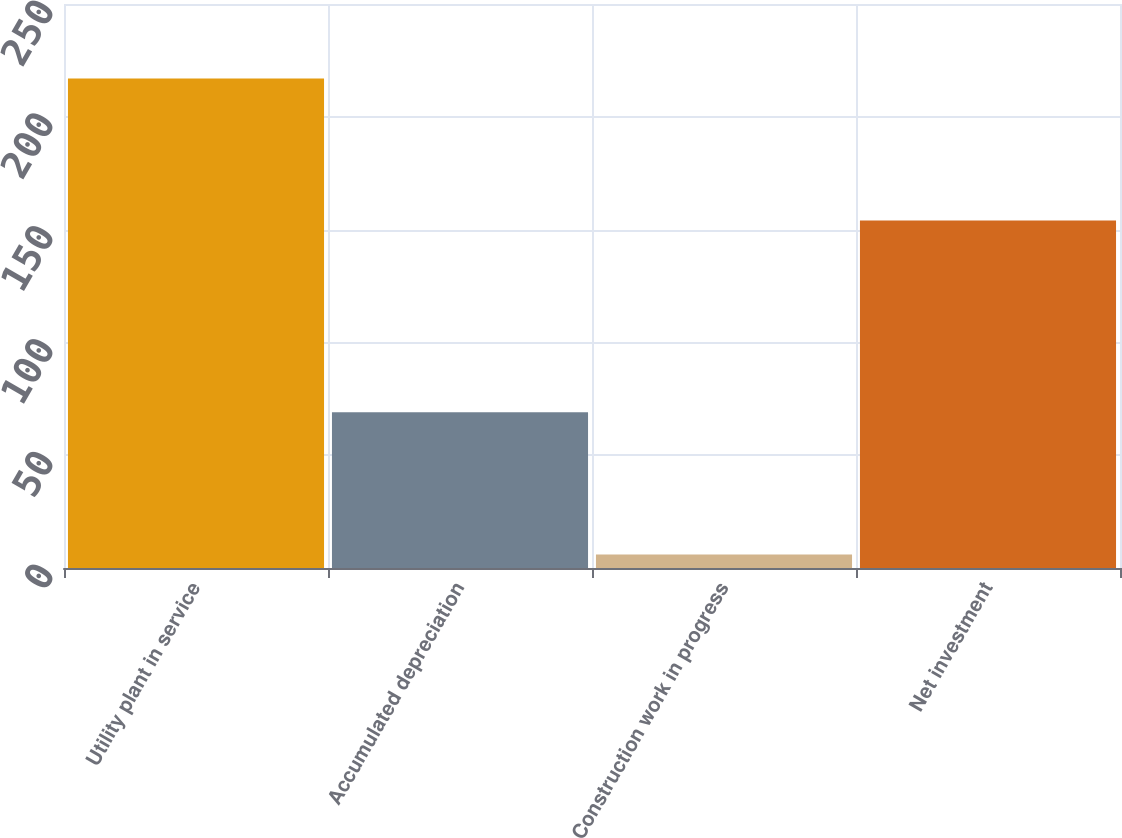Convert chart to OTSL. <chart><loc_0><loc_0><loc_500><loc_500><bar_chart><fcel>Utility plant in service<fcel>Accumulated depreciation<fcel>Construction work in progress<fcel>Net investment<nl><fcel>217<fcel>69<fcel>6<fcel>154<nl></chart> 